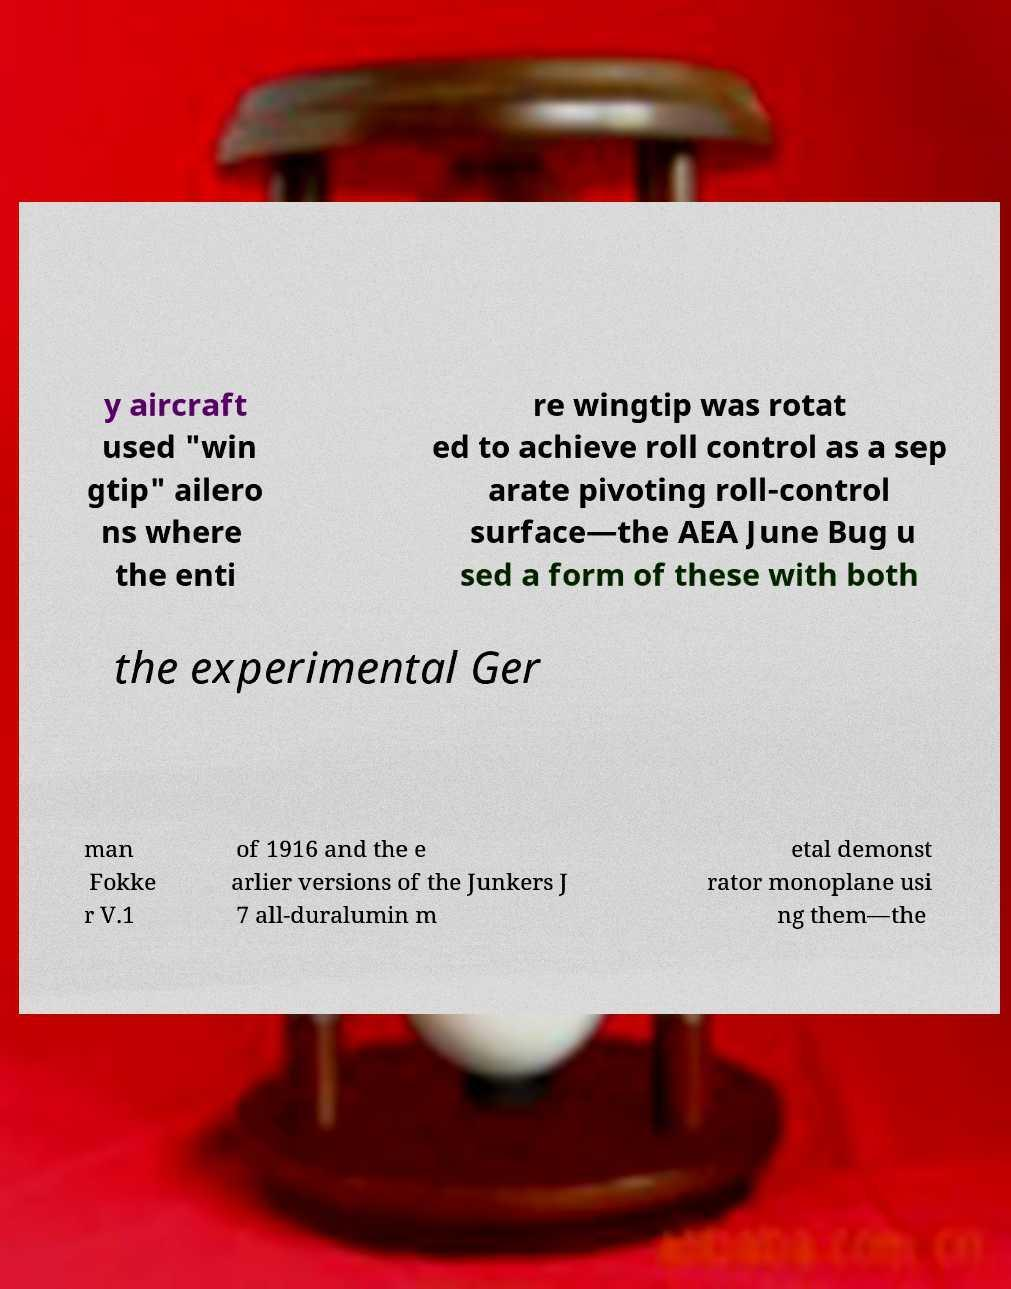Can you read and provide the text displayed in the image?This photo seems to have some interesting text. Can you extract and type it out for me? y aircraft used "win gtip" ailero ns where the enti re wingtip was rotat ed to achieve roll control as a sep arate pivoting roll-control surface—the AEA June Bug u sed a form of these with both the experimental Ger man Fokke r V.1 of 1916 and the e arlier versions of the Junkers J 7 all-duralumin m etal demonst rator monoplane usi ng them—the 